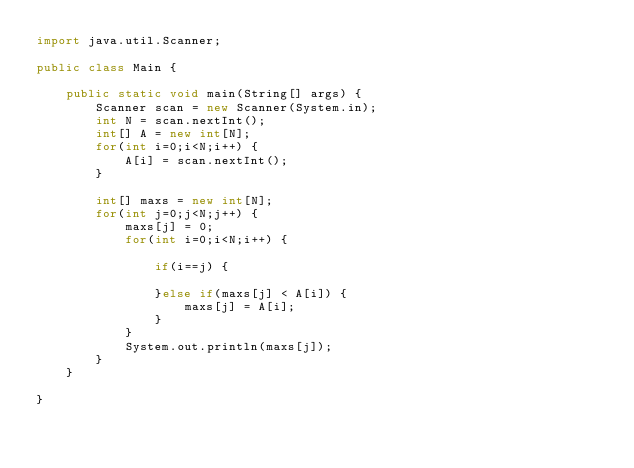Convert code to text. <code><loc_0><loc_0><loc_500><loc_500><_Java_>import java.util.Scanner;

public class Main {

	public static void main(String[] args) {
		Scanner scan = new Scanner(System.in);
		int N = scan.nextInt();
		int[] A = new int[N];
		for(int i=0;i<N;i++) {
			A[i] = scan.nextInt();
		}

		int[] maxs = new int[N];
		for(int j=0;j<N;j++) {
			maxs[j] = 0;
			for(int i=0;i<N;i++) {

				if(i==j) {

				}else if(maxs[j] < A[i]) {
					maxs[j] = A[i];
				}
			}
			System.out.println(maxs[j]);
		}
	}

}</code> 